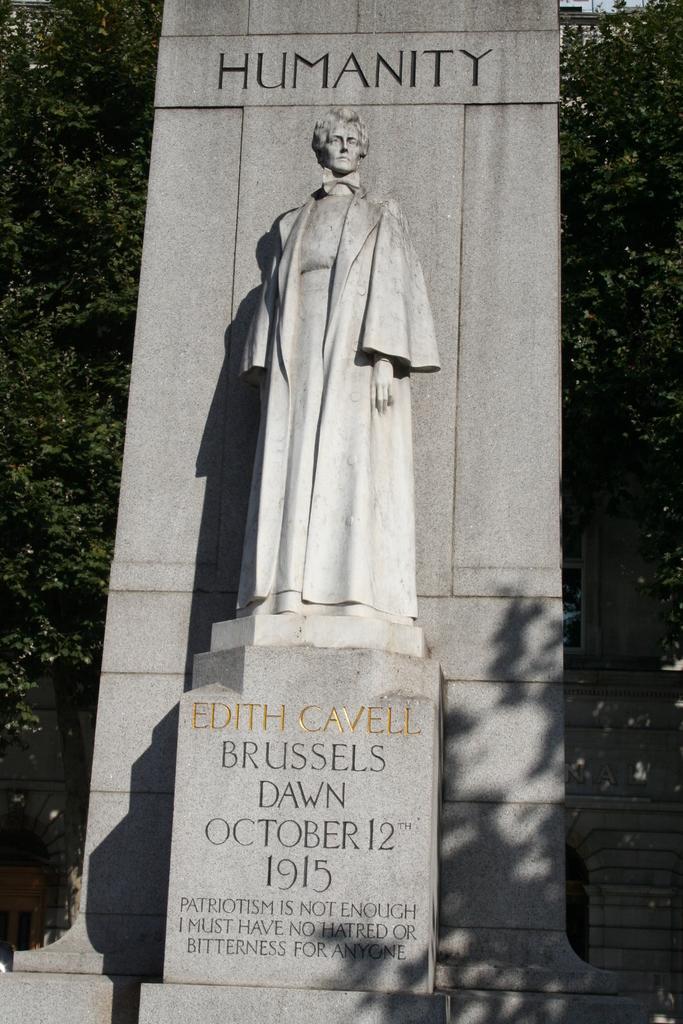Describe this image in one or two sentences. In the center of the image there is a statue. In the background there are trees. 